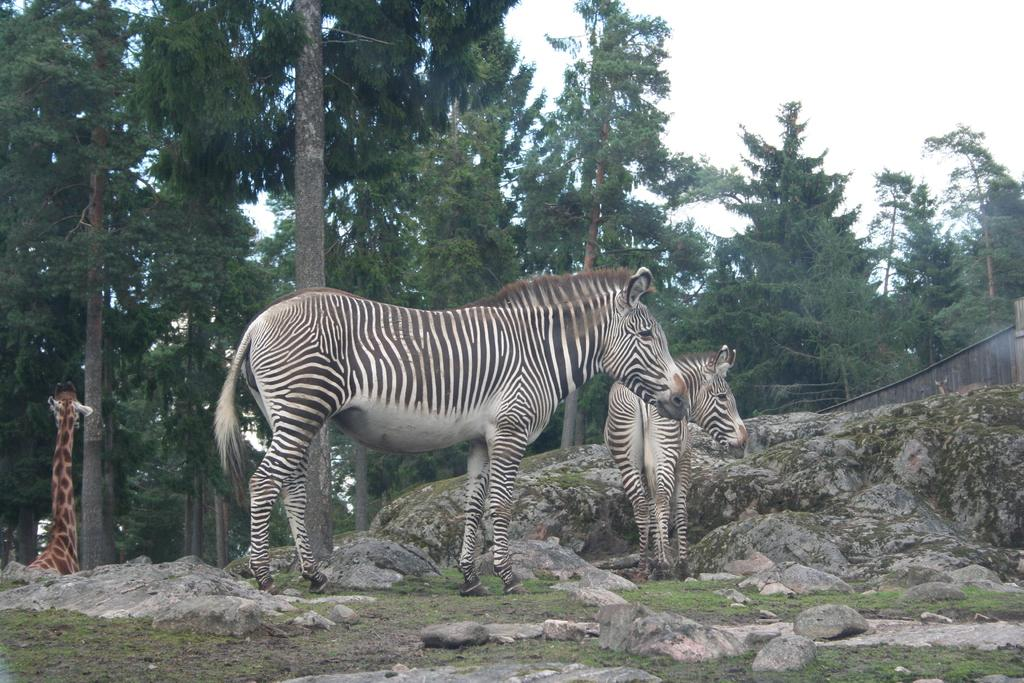What type of terrain is visible in the image? There is an open ground in the image. What is covering the ground? There is grass on the ground, and there are also rocks visible. How many zebras are in the image? There are 2 zebras in the image. What other animal can be seen in the image? There is a giraffe in the image. What can be seen in the background of the image? There are trees and the sky visible in the background. Can you tell me how many pets are accompanying the beggar in the image? There is no beggar or pets present in the image. What type of day is it in the image? The provided facts do not mention the time of day or weather conditions, so it cannot be determined from the image. 